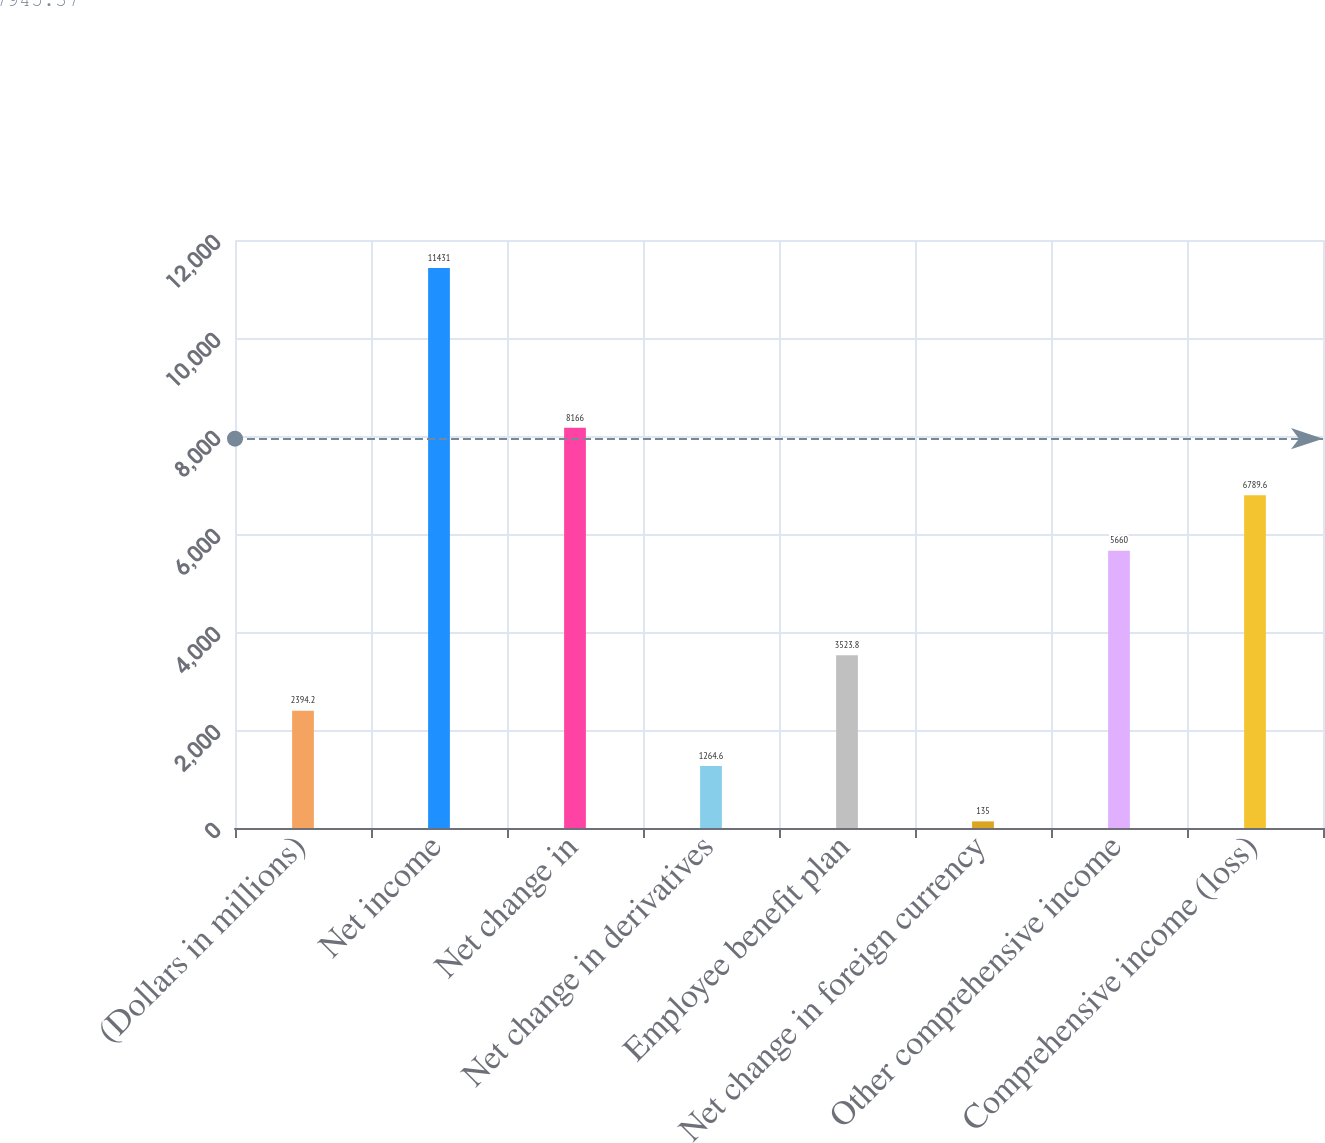<chart> <loc_0><loc_0><loc_500><loc_500><bar_chart><fcel>(Dollars in millions)<fcel>Net income<fcel>Net change in<fcel>Net change in derivatives<fcel>Employee benefit plan<fcel>Net change in foreign currency<fcel>Other comprehensive income<fcel>Comprehensive income (loss)<nl><fcel>2394.2<fcel>11431<fcel>8166<fcel>1264.6<fcel>3523.8<fcel>135<fcel>5660<fcel>6789.6<nl></chart> 